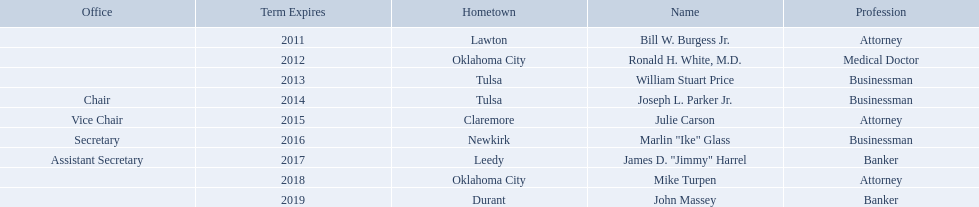Who are the state regents? Bill W. Burgess Jr., Ronald H. White, M.D., William Stuart Price, Joseph L. Parker Jr., Julie Carson, Marlin "Ike" Glass, James D. "Jimmy" Harrel, Mike Turpen, John Massey. Of those state regents, who is from the same hometown as ronald h. white, m.d.? Mike Turpen. 